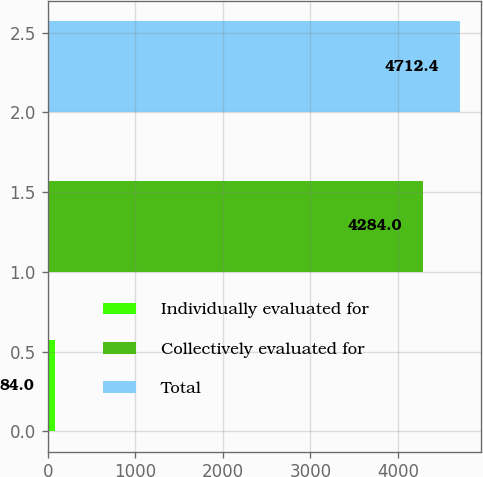<chart> <loc_0><loc_0><loc_500><loc_500><bar_chart><fcel>Individually evaluated for<fcel>Collectively evaluated for<fcel>Total<nl><fcel>84<fcel>4284<fcel>4712.4<nl></chart> 